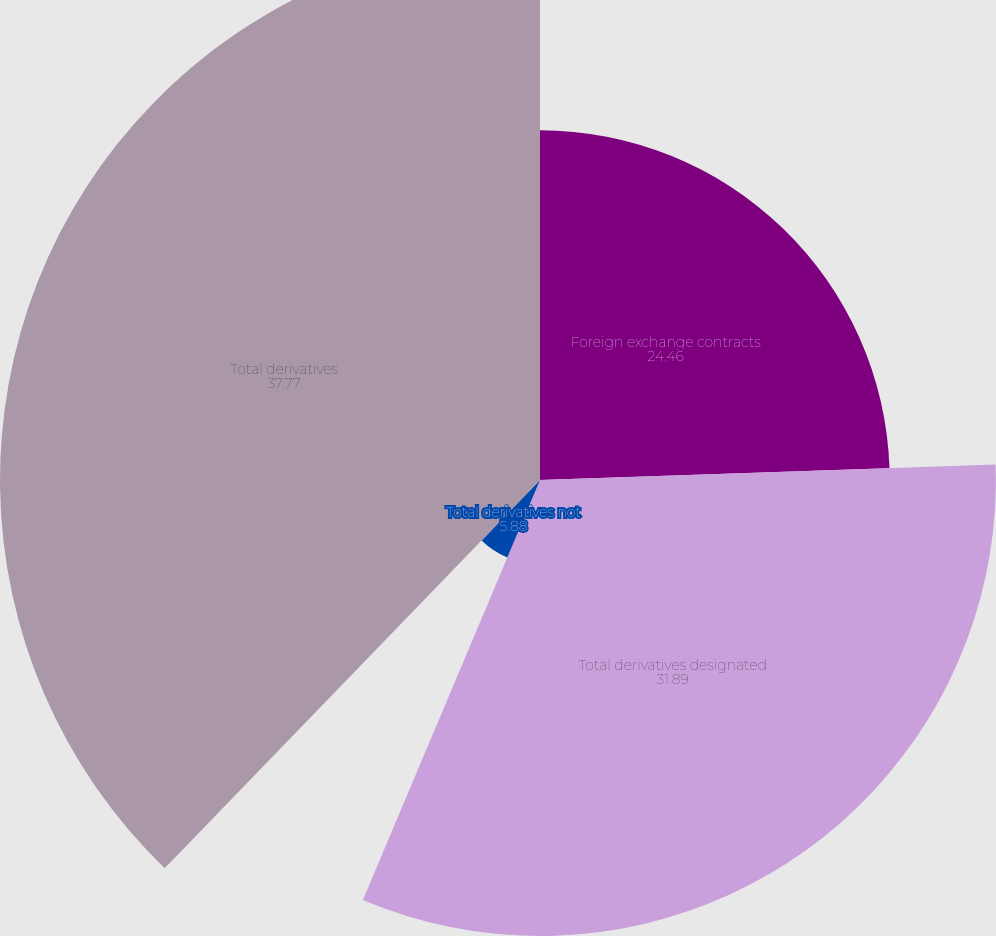Convert chart. <chart><loc_0><loc_0><loc_500><loc_500><pie_chart><fcel>Foreign exchange contracts<fcel>Total derivatives designated<fcel>Total derivatives not<fcel>Total derivatives<nl><fcel>24.46%<fcel>31.89%<fcel>5.88%<fcel>37.77%<nl></chart> 